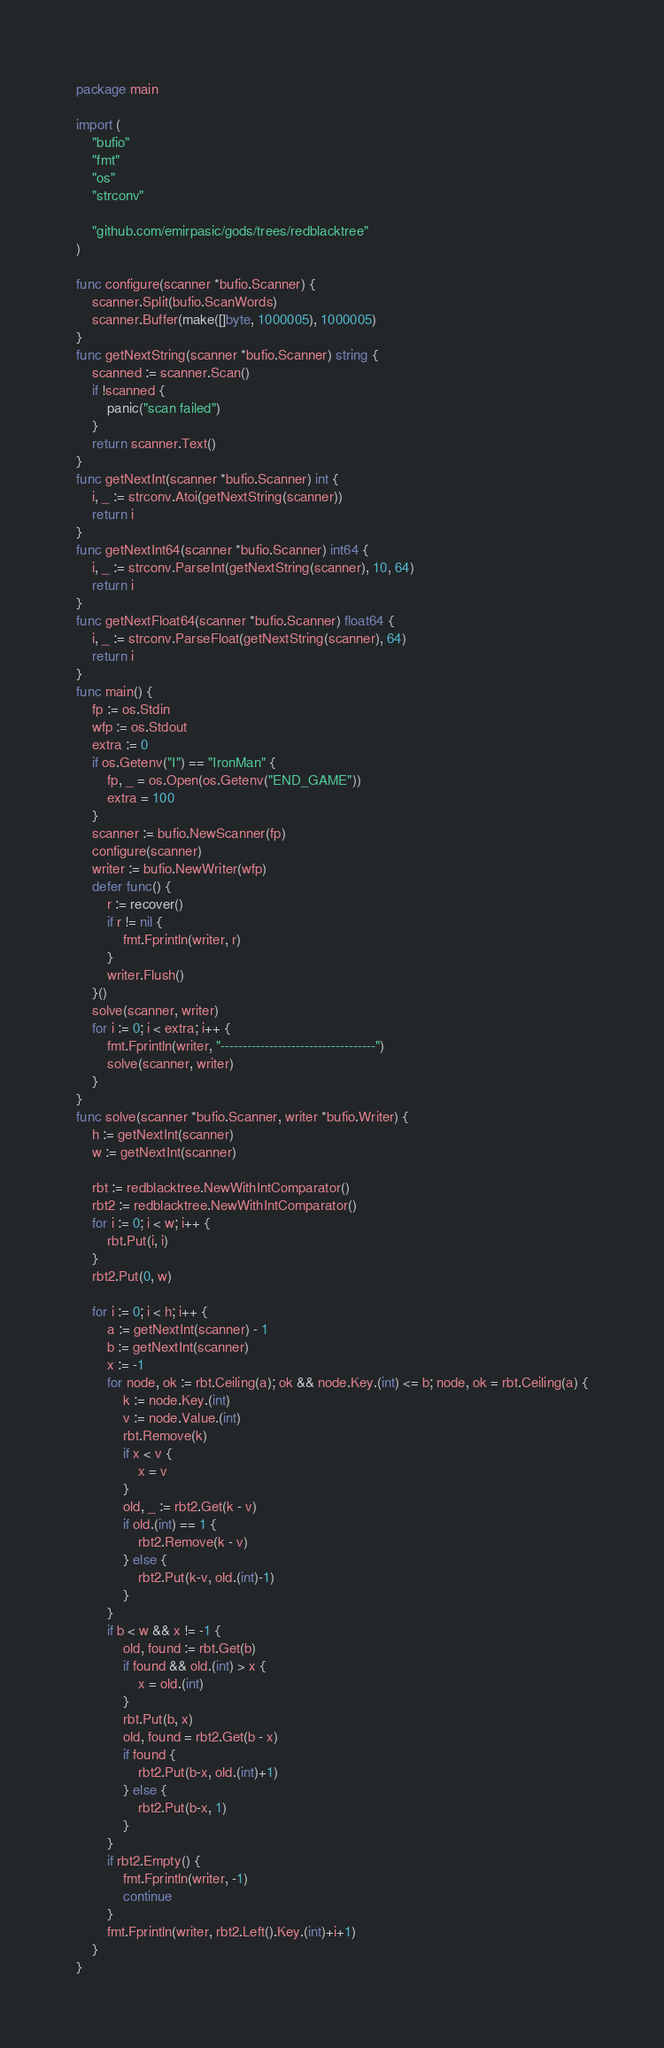<code> <loc_0><loc_0><loc_500><loc_500><_Go_>package main

import (
	"bufio"
	"fmt"
	"os"
	"strconv"

	"github.com/emirpasic/gods/trees/redblacktree"
)

func configure(scanner *bufio.Scanner) {
	scanner.Split(bufio.ScanWords)
	scanner.Buffer(make([]byte, 1000005), 1000005)
}
func getNextString(scanner *bufio.Scanner) string {
	scanned := scanner.Scan()
	if !scanned {
		panic("scan failed")
	}
	return scanner.Text()
}
func getNextInt(scanner *bufio.Scanner) int {
	i, _ := strconv.Atoi(getNextString(scanner))
	return i
}
func getNextInt64(scanner *bufio.Scanner) int64 {
	i, _ := strconv.ParseInt(getNextString(scanner), 10, 64)
	return i
}
func getNextFloat64(scanner *bufio.Scanner) float64 {
	i, _ := strconv.ParseFloat(getNextString(scanner), 64)
	return i
}
func main() {
	fp := os.Stdin
	wfp := os.Stdout
	extra := 0
	if os.Getenv("I") == "IronMan" {
		fp, _ = os.Open(os.Getenv("END_GAME"))
		extra = 100
	}
	scanner := bufio.NewScanner(fp)
	configure(scanner)
	writer := bufio.NewWriter(wfp)
	defer func() {
		r := recover()
		if r != nil {
			fmt.Fprintln(writer, r)
		}
		writer.Flush()
	}()
	solve(scanner, writer)
	for i := 0; i < extra; i++ {
		fmt.Fprintln(writer, "-----------------------------------")
		solve(scanner, writer)
	}
}
func solve(scanner *bufio.Scanner, writer *bufio.Writer) {
	h := getNextInt(scanner)
	w := getNextInt(scanner)

	rbt := redblacktree.NewWithIntComparator()
	rbt2 := redblacktree.NewWithIntComparator()
	for i := 0; i < w; i++ {
		rbt.Put(i, i)
	}
	rbt2.Put(0, w)

	for i := 0; i < h; i++ {
		a := getNextInt(scanner) - 1
		b := getNextInt(scanner)
		x := -1
		for node, ok := rbt.Ceiling(a); ok && node.Key.(int) <= b; node, ok = rbt.Ceiling(a) {
			k := node.Key.(int)
			v := node.Value.(int)
			rbt.Remove(k)
			if x < v {
				x = v
			}
			old, _ := rbt2.Get(k - v)
			if old.(int) == 1 {
				rbt2.Remove(k - v)
			} else {
				rbt2.Put(k-v, old.(int)-1)
			}
		}
		if b < w && x != -1 {
			old, found := rbt.Get(b)
			if found && old.(int) > x {
				x = old.(int)
			}
			rbt.Put(b, x)
			old, found = rbt2.Get(b - x)
			if found {
				rbt2.Put(b-x, old.(int)+1)
			} else {
				rbt2.Put(b-x, 1)
			}
		}
		if rbt2.Empty() {
			fmt.Fprintln(writer, -1)
			continue
		}
		fmt.Fprintln(writer, rbt2.Left().Key.(int)+i+1)
	}
}
</code> 